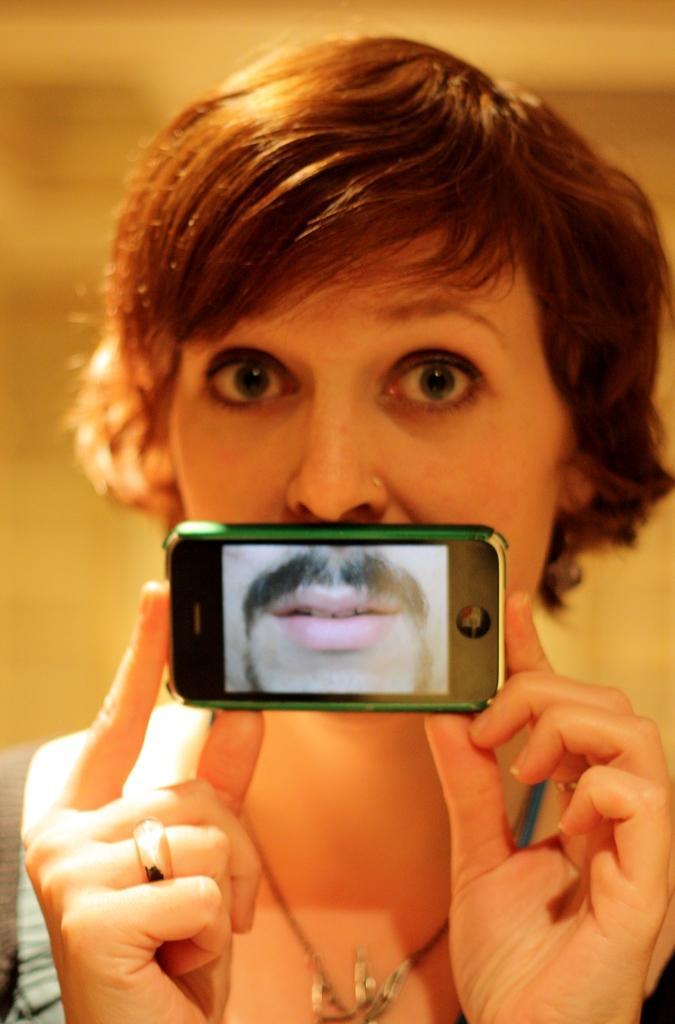Could you give a brief overview of what you see in this image? This person is holding a mobile and looking forward. 